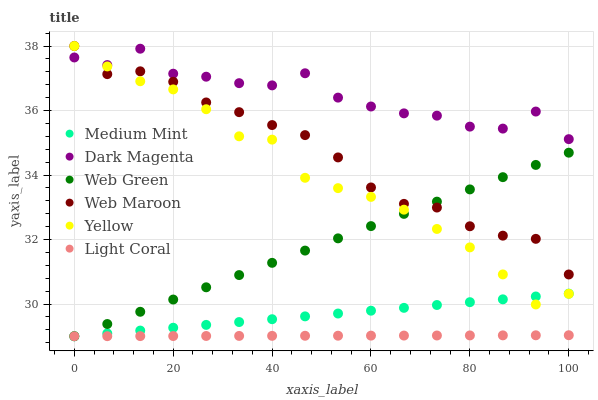Does Light Coral have the minimum area under the curve?
Answer yes or no. Yes. Does Dark Magenta have the maximum area under the curve?
Answer yes or no. Yes. Does Web Maroon have the minimum area under the curve?
Answer yes or no. No. Does Web Maroon have the maximum area under the curve?
Answer yes or no. No. Is Medium Mint the smoothest?
Answer yes or no. Yes. Is Dark Magenta the roughest?
Answer yes or no. Yes. Is Web Maroon the smoothest?
Answer yes or no. No. Is Web Maroon the roughest?
Answer yes or no. No. Does Medium Mint have the lowest value?
Answer yes or no. Yes. Does Web Maroon have the lowest value?
Answer yes or no. No. Does Yellow have the highest value?
Answer yes or no. Yes. Does Dark Magenta have the highest value?
Answer yes or no. No. Is Medium Mint less than Web Maroon?
Answer yes or no. Yes. Is Web Maroon greater than Light Coral?
Answer yes or no. Yes. Does Dark Magenta intersect Yellow?
Answer yes or no. Yes. Is Dark Magenta less than Yellow?
Answer yes or no. No. Is Dark Magenta greater than Yellow?
Answer yes or no. No. Does Medium Mint intersect Web Maroon?
Answer yes or no. No. 